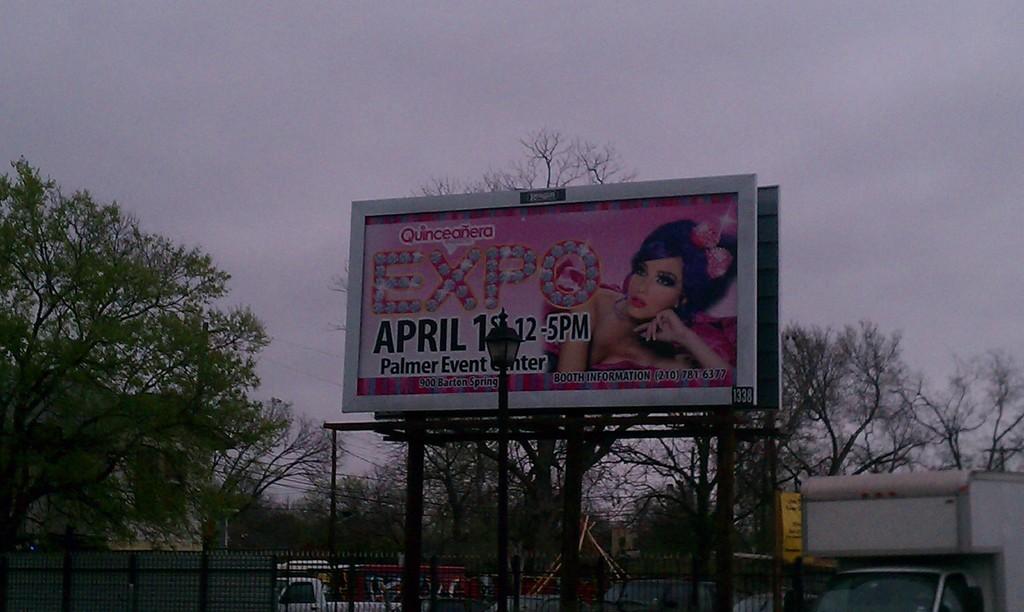What month is it on the sign?
Your answer should be compact. April. 